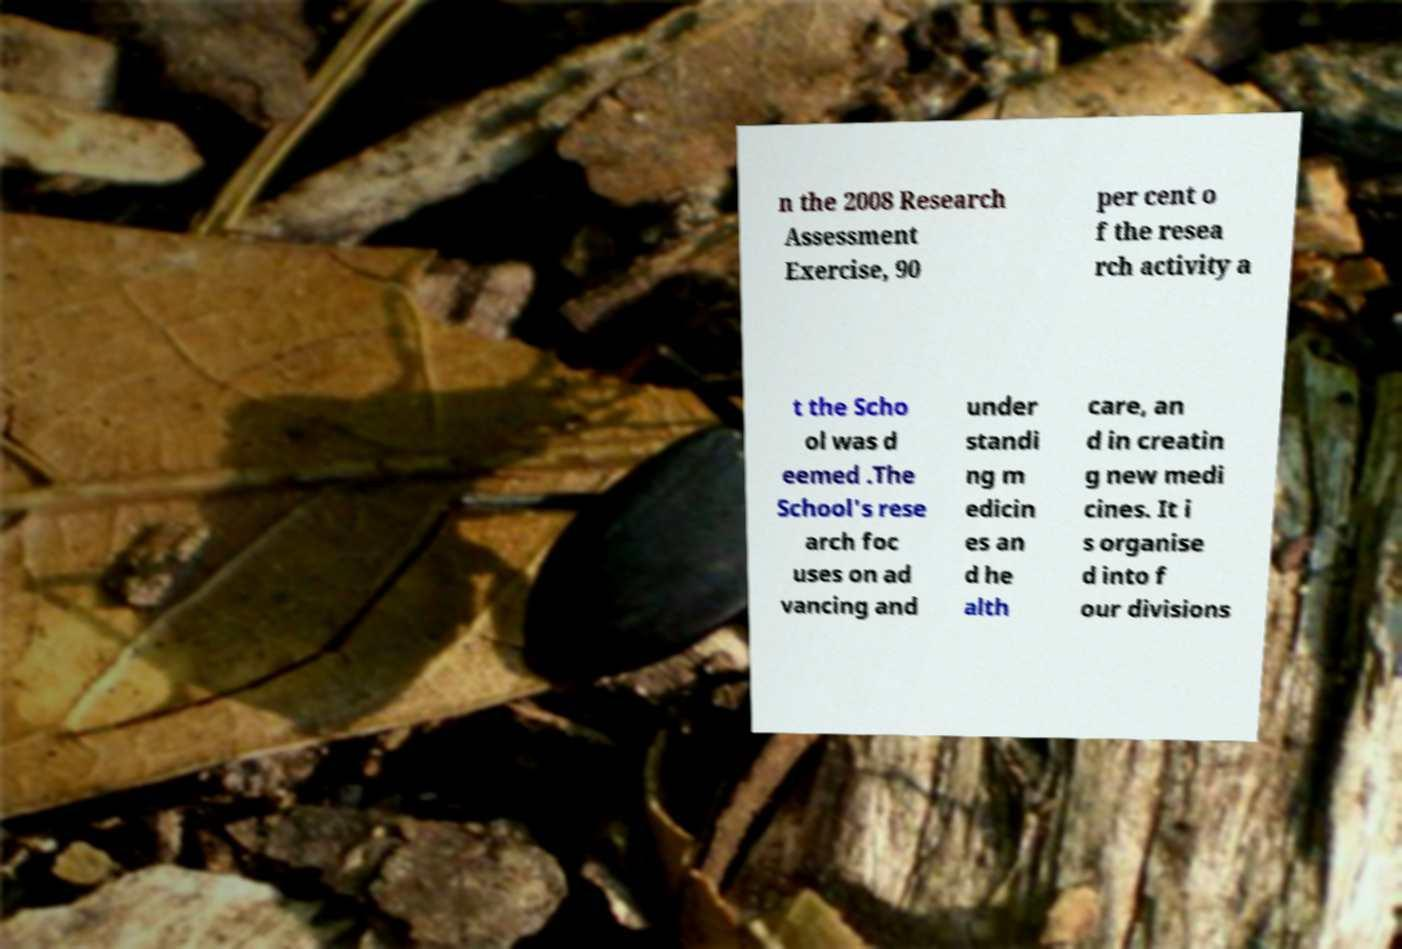What messages or text are displayed in this image? I need them in a readable, typed format. n the 2008 Research Assessment Exercise, 90 per cent o f the resea rch activity a t the Scho ol was d eemed .The School's rese arch foc uses on ad vancing and under standi ng m edicin es an d he alth care, an d in creatin g new medi cines. It i s organise d into f our divisions 